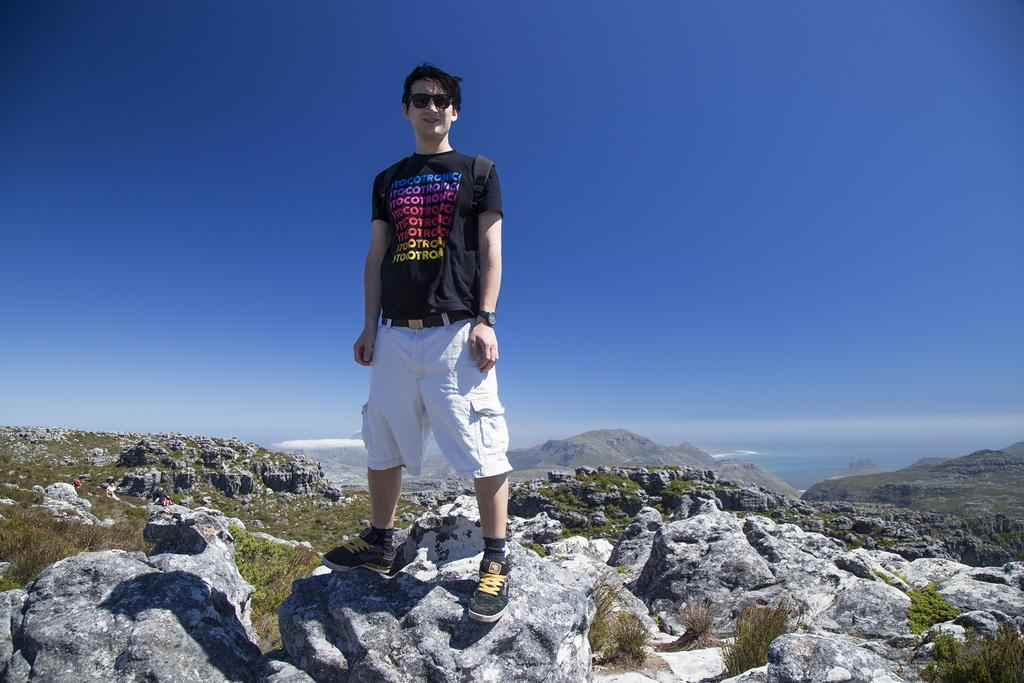Who is present in the image? There is a man in the image. What is the man wearing? The man is wearing a black t-shirt. Where is the man standing? The man is standing on a rock. What can be seen in the background of the image? There are hills, grass, and the sky visible in the background of the image. How many screws can be seen in the image? There are no screws present in the image. What type of planes are flying in the image? There are no planes visible in the image. 